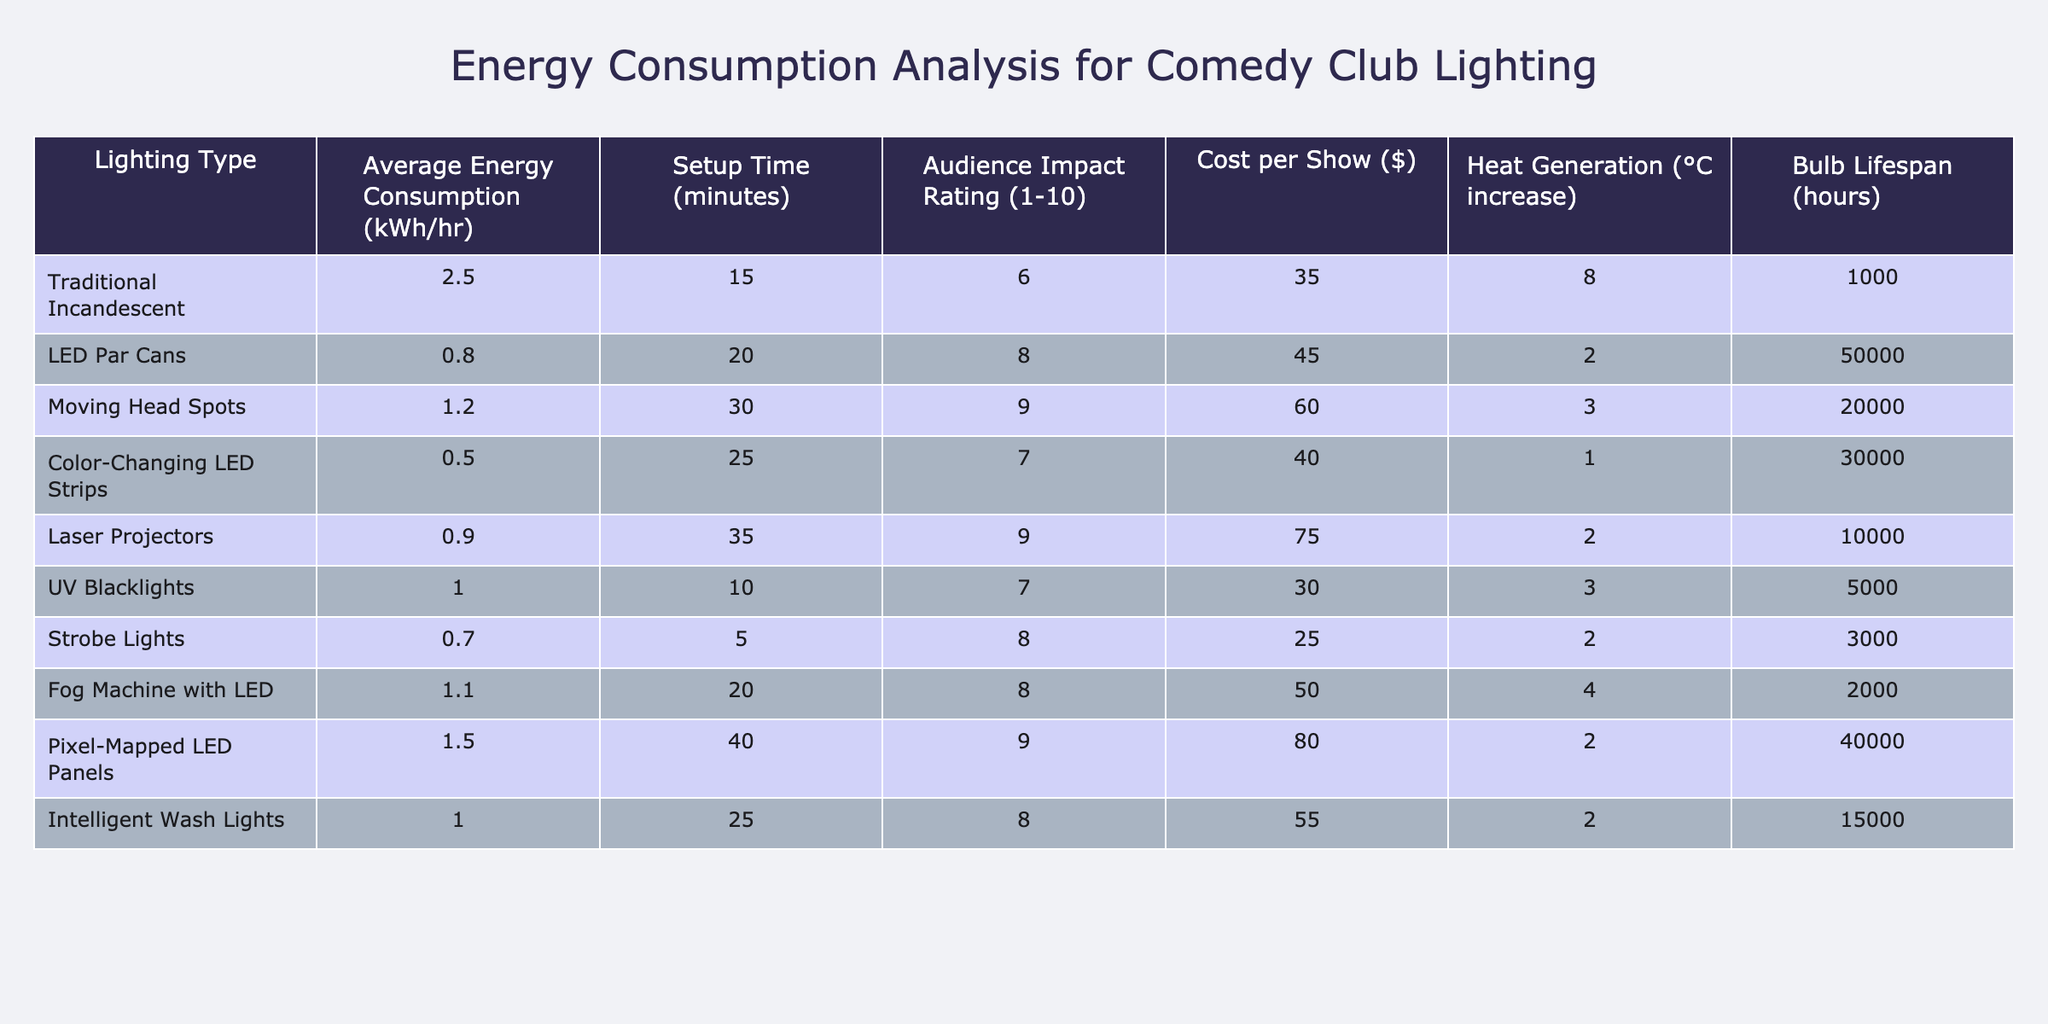What is the average energy consumption of LED Par Cans? The table shows the average energy consumption (kWh/hr) for LED Par Cans is listed as 0.8.
Answer: 0.8 Which lighting type has the highest audience impact rating? Looking at the audience impact rating, the highest value is 9, which corresponds to both Moving Head Spots and Laser Projectors.
Answer: Moving Head Spots and Laser Projectors What is the total cost per show for Color-Changing LED Strips and Strobe Lights combined? The cost per show for Color-Changing LED Strips is $40 and for Strobe Lights is $25. Adding these gives 40 + 25 = 65.
Answer: 65 What is the difference in heat generation between Traditional Incandescent and Intelligent Wash Lights? The heat generation for Traditional Incandescent is 8°C and for Intelligent Wash Lights is 2°C. The difference is 8 - 2 = 6°C.
Answer: 6°C Is the bulb lifespan of the LED Par Cans longer than that of UV Blacklights? The bulb lifespan for LED Par Cans is 50,000 hours, while for UV Blacklights, it is 5,000 hours. Since 50,000 > 5,000, the statement is true.
Answer: Yes Which lighting type has the lowest setup time, and what is that time? Strobe Lights have the lowest setup time of 5 minutes as per the table.
Answer: 5 minutes If a comedy show lasts for 3 hours with Moving Head Spots lighting, how much energy is consumed? The average energy consumption for Moving Head Spots is 1.2 kWh/hr. For 3 hours, the total is 1.2 * 3 = 3.6 kWh.
Answer: 3.6 kWh Which lighting type generates the least heat? From the table, Color-Changing LED Strips generate 1°C of heat, which is less than any other lighting type listed.
Answer: Color-Changing LED Strips What is the average setup time for all lighting types listed? The total setup times are: 15 + 20 + 30 + 25 + 35 + 10 + 5 + 20 + 40 + 25 =  235 minutes. Dividing by 10 (the number of lighting types) gives an average of 23.5 minutes.
Answer: 23.5 minutes Which lighting type has the highest cost per show, and what is the cost? The highest cost per show is for Laser Projectors at $75 according to the data presented in the table.
Answer: $75 